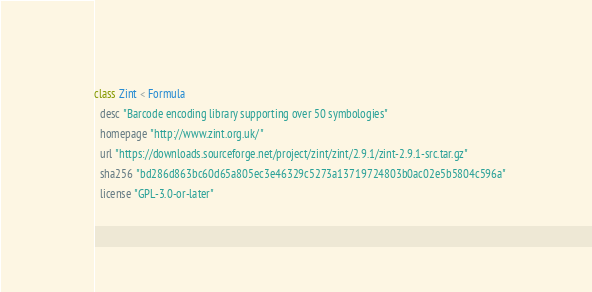<code> <loc_0><loc_0><loc_500><loc_500><_Ruby_>class Zint < Formula
  desc "Barcode encoding library supporting over 50 symbologies"
  homepage "http://www.zint.org.uk/"
  url "https://downloads.sourceforge.net/project/zint/zint/2.9.1/zint-2.9.1-src.tar.gz"
  sha256 "bd286d863bc60d65a805ec3e46329c5273a13719724803b0ac02e5b5804c596a"
  license "GPL-3.0-or-later"</code> 